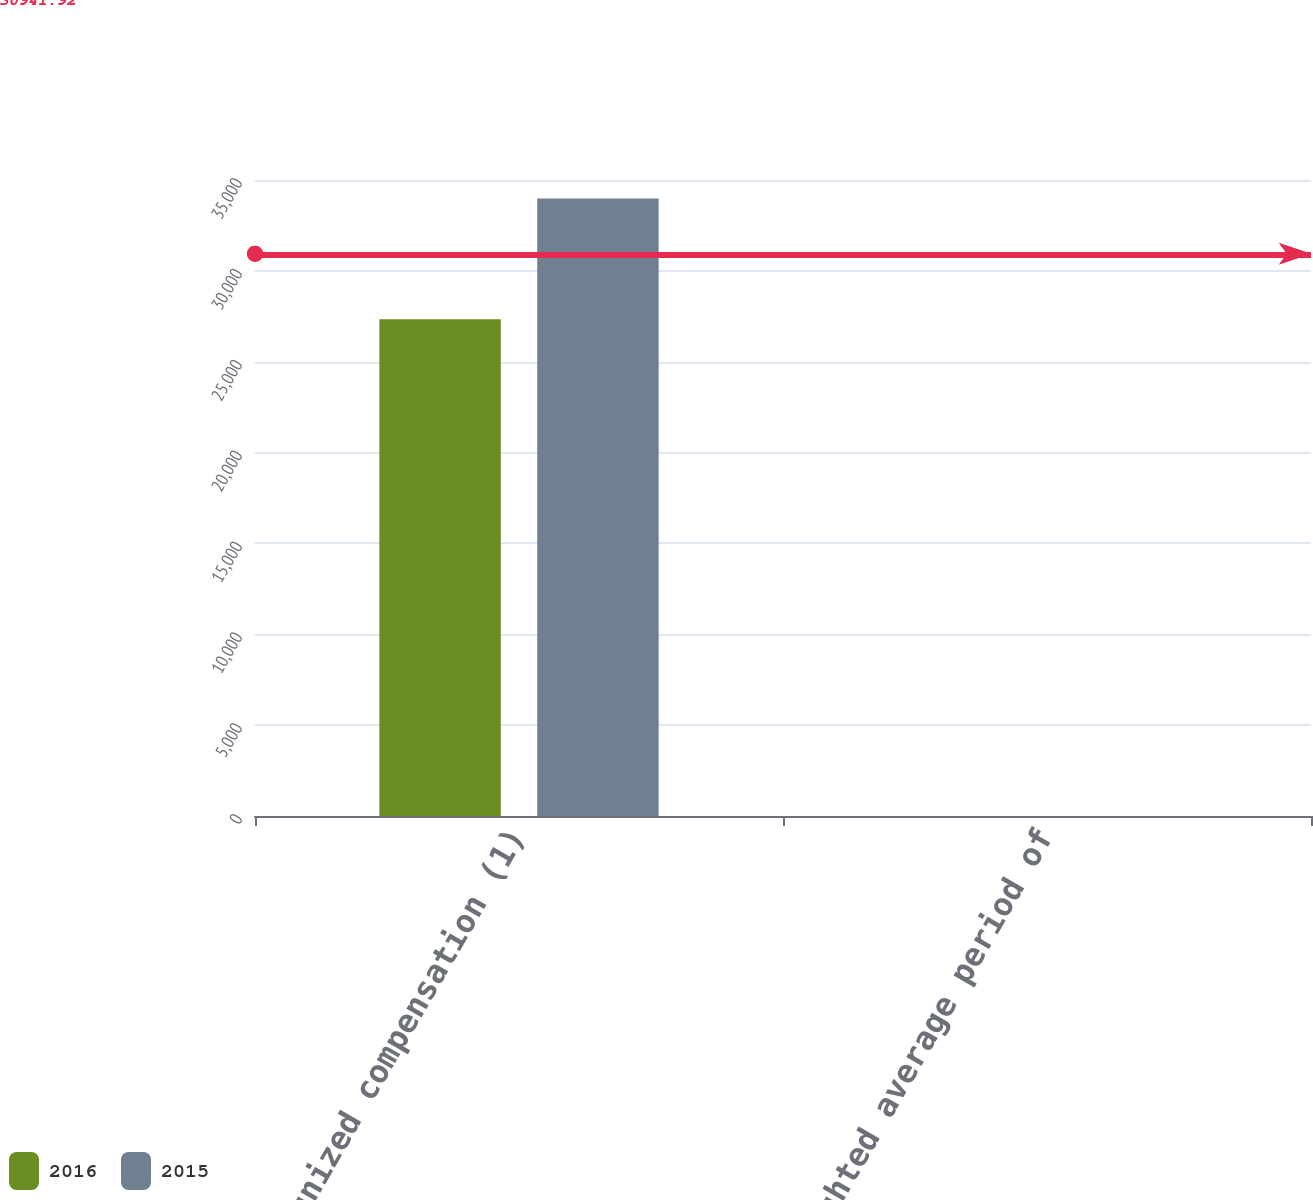Convert chart. <chart><loc_0><loc_0><loc_500><loc_500><stacked_bar_chart><ecel><fcel>Unrecognized compensation (1)<fcel>Weighted average period of<nl><fcel>2016<fcel>27334<fcel>0.89<nl><fcel>2015<fcel>33977<fcel>0.85<nl></chart> 